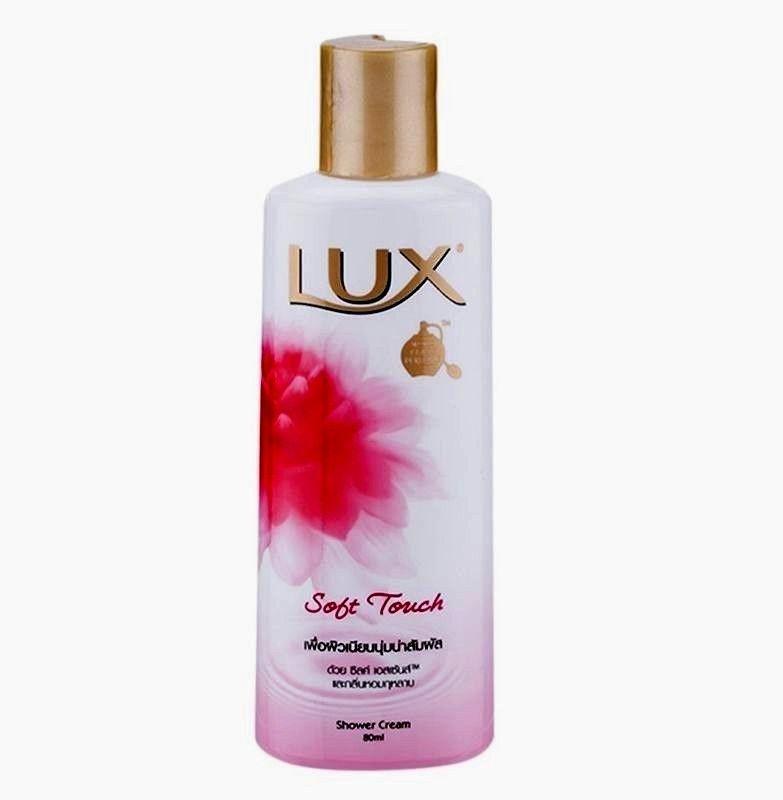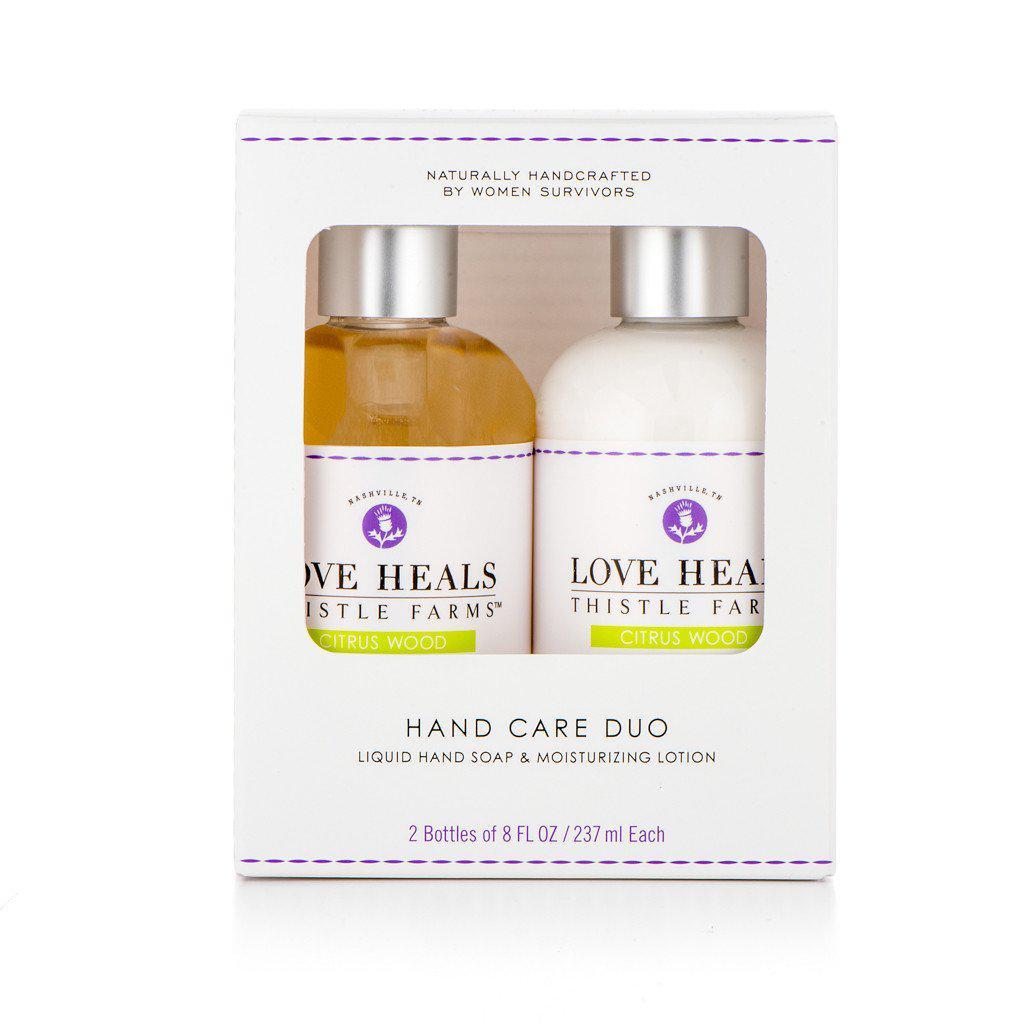The first image is the image on the left, the second image is the image on the right. Considering the images on both sides, is "Some items are laying flat." valid? Answer yes or no. No. 